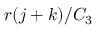<formula> <loc_0><loc_0><loc_500><loc_500>r ( j + k ) / C _ { 3 }</formula> 